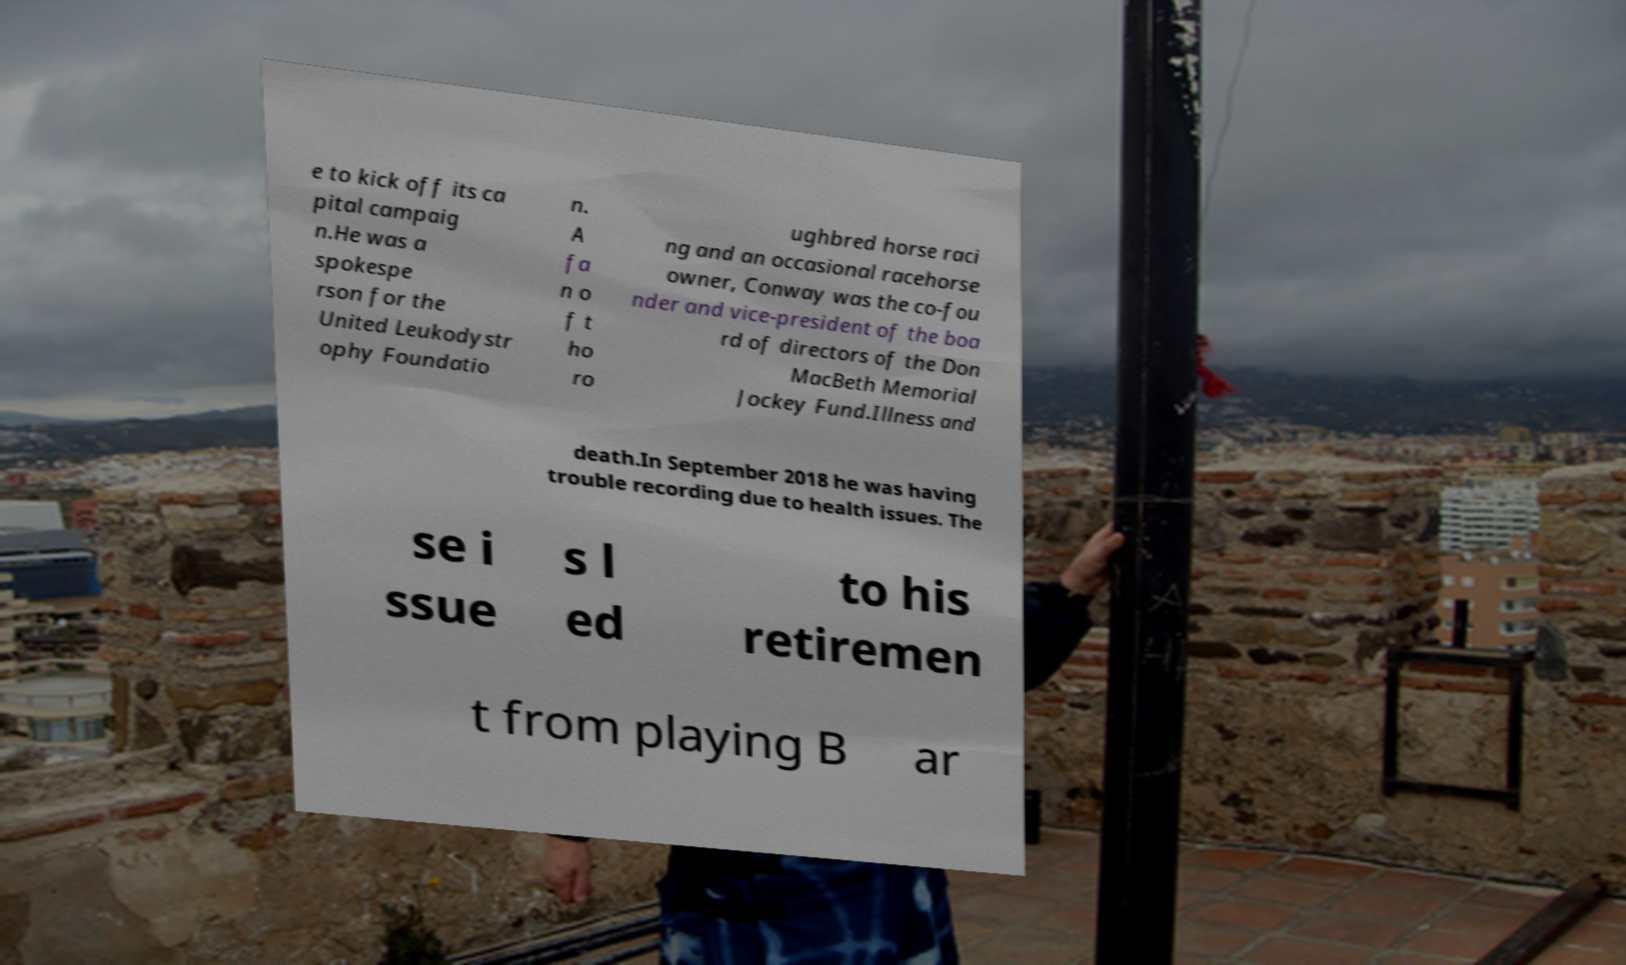There's text embedded in this image that I need extracted. Can you transcribe it verbatim? e to kick off its ca pital campaig n.He was a spokespe rson for the United Leukodystr ophy Foundatio n. A fa n o f t ho ro ughbred horse raci ng and an occasional racehorse owner, Conway was the co-fou nder and vice-president of the boa rd of directors of the Don MacBeth Memorial Jockey Fund.Illness and death.In September 2018 he was having trouble recording due to health issues. The se i ssue s l ed to his retiremen t from playing B ar 